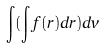Convert formula to latex. <formula><loc_0><loc_0><loc_500><loc_500>\int ( \int f ( r ) d r ) d v</formula> 